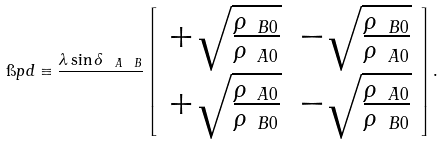<formula> <loc_0><loc_0><loc_500><loc_500>\i p d \equiv \frac { \lambda \sin \delta _ { \ A \ B } } { } \left [ \begin{array} { c c } + \sqrt { \frac { \rho _ { \ B 0 } } { \rho _ { \ A 0 } } } & - \sqrt { \frac { \rho _ { \ B 0 } } { \rho _ { \ A 0 } } } \\ + \sqrt { \frac { \rho _ { \ A 0 } } { \rho _ { \ B 0 } } } & - \sqrt { \frac { \rho _ { \ A 0 } } { \rho _ { \ B 0 } } } \\ \end{array} \right ] .</formula> 